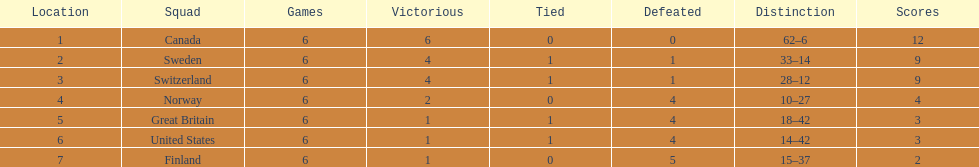How many teams won at least 2 games throughout the 1951 world ice hockey championships? 4. 